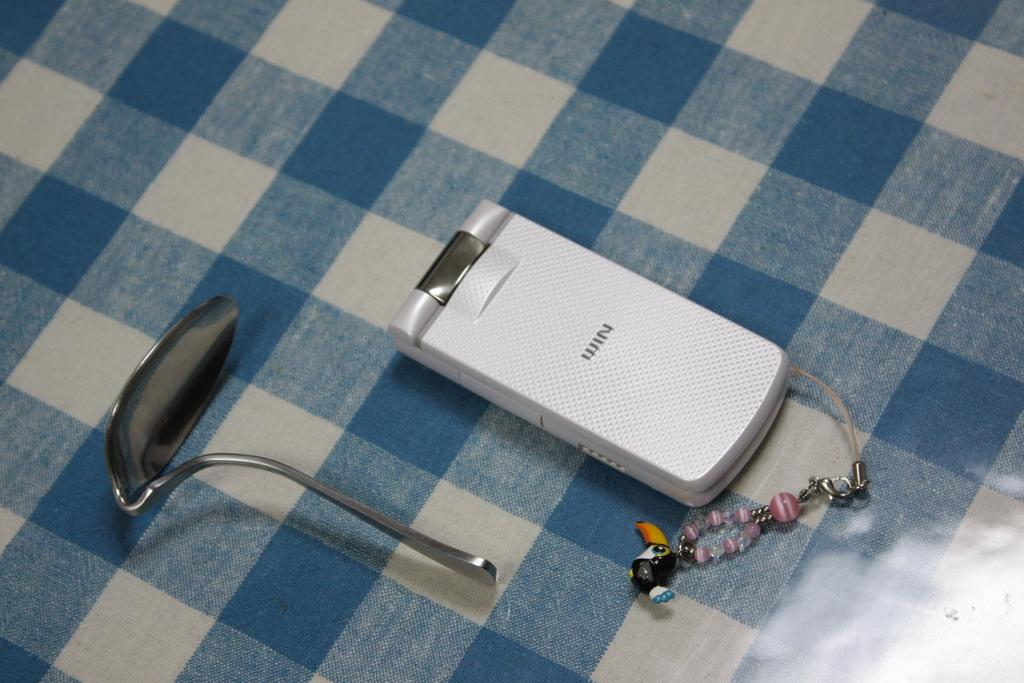<image>
Summarize the visual content of the image. A bended spoon and old foldable cell-phone called WIN are on the table 